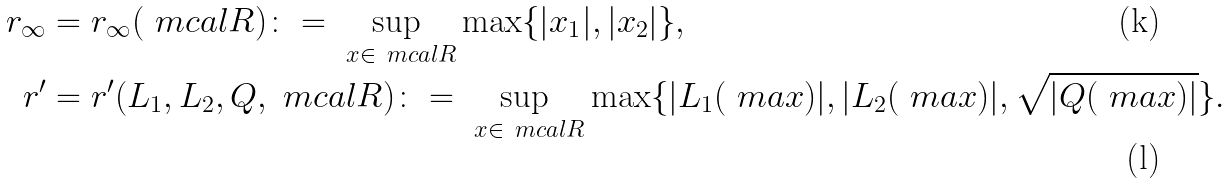<formula> <loc_0><loc_0><loc_500><loc_500>r _ { \infty } & = r _ { \infty } ( \ m c a l { R } ) \colon = \sup _ { \ x \in \ m c a l { R } } \max \{ | x _ { 1 } | , | x _ { 2 } | \} , \\ r ^ { \prime } & = r ^ { \prime } ( L _ { 1 } , L _ { 2 } , Q , \ m c a l { R } ) \colon = \sup _ { \ x \in \ m c a l { R } } \max \{ | L _ { 1 } ( \ m a { x } ) | , | L _ { 2 } ( \ m a { x } ) | , \sqrt { | Q ( \ m a { x } ) | } \} .</formula> 